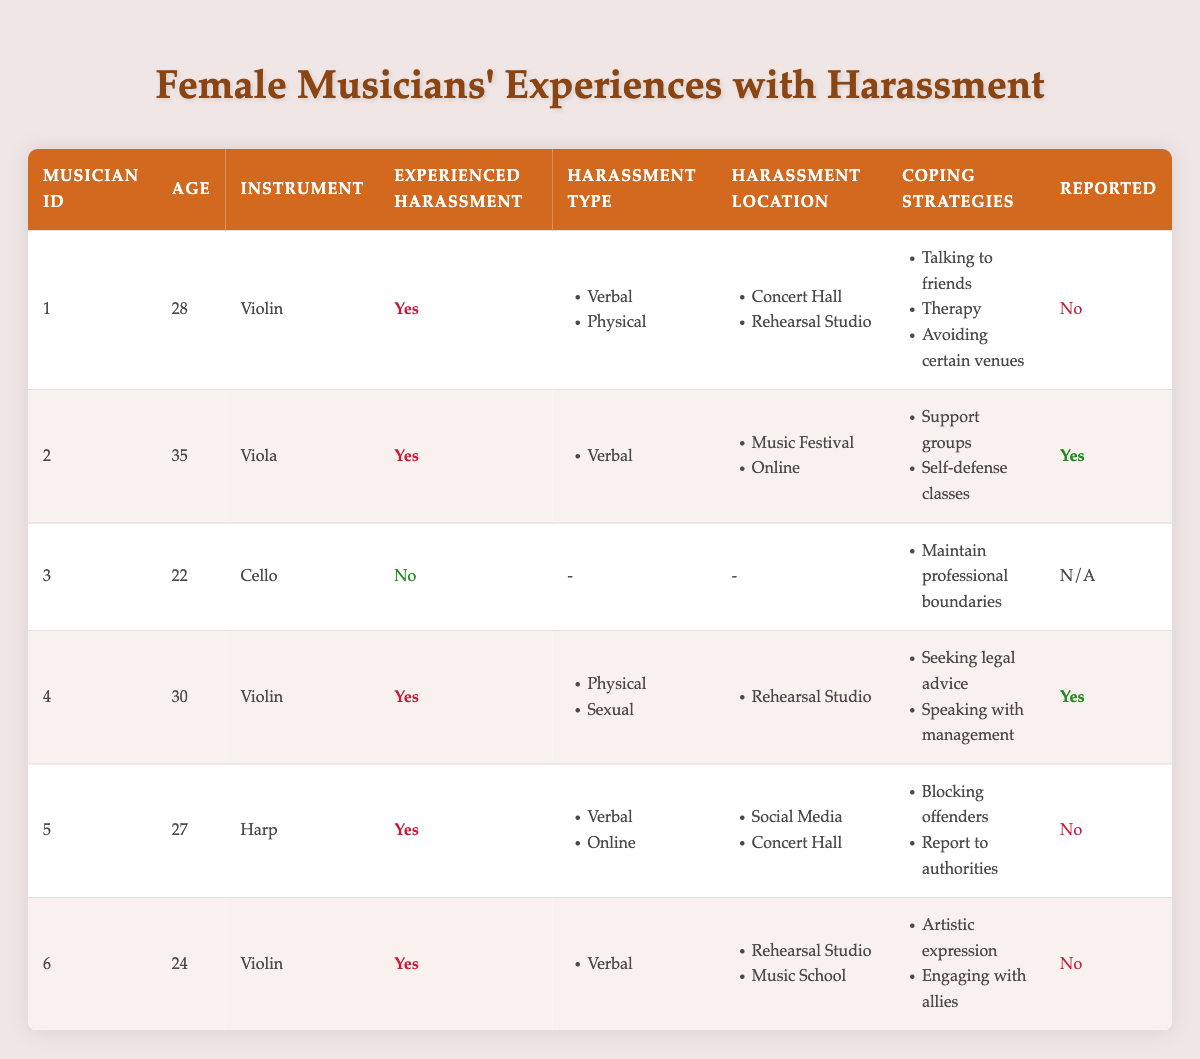What percentage of musicians experienced harassment? There are 6 musicians in total, and 5 of them indicated that they experienced harassment. To find the percentage: (5/6) * 100 = 83.33%.
Answer: 83.33% How many musicians reported their harassment cases? Out of the 6 musicians, 2 reported their harassment cases.
Answer: 2 What are the coping strategies used by the musician who experienced sexual harassment? Musician ID 4 experienced sexual harassment and their coping strategies were seeking legal advice and speaking with management.
Answer: Seeking legal advice, speaking with management Which instrument is associated with the highest number of harassment experiences? The violin has 3 musicians who reported experiencing harassment (IDs 1, 4, and 6). Other instruments have fewer instances.
Answer: Violin Is there a musician who did not experience harassment? Musician ID 3 indicated they did not experience harassment.
Answer: Yes What is the most common type of harassment reported by the musicians? The types of harassment reported are verbal, physical, and sexual. Verbal harassment appears the most frequently.
Answer: Verbal What is the average age of musicians who reported harassment? The ages of musicians who reported harassment are 28, 35, 30, 27, and 24. The average is (28 + 35 + 30 + 27 + 24) / 5 = 28.8 years.
Answer: 28.8 How many types of harassment did the musician aged 28 report? Musician ID 1, aged 28, reported experiencing 2 types of harassment: verbal and physical.
Answer: 2 Among the musicians who experienced harassment, how many have utilized artistic expression as a coping strategy? Only Musician ID 6 indicated using artistic expression as a coping strategy, while others used different strategies.
Answer: 1 Was there any musician who avoided certain venues as a coping strategy? Musician ID 1 reported avoiding certain venues as a coping strategy after experiencing harassment.
Answer: Yes 